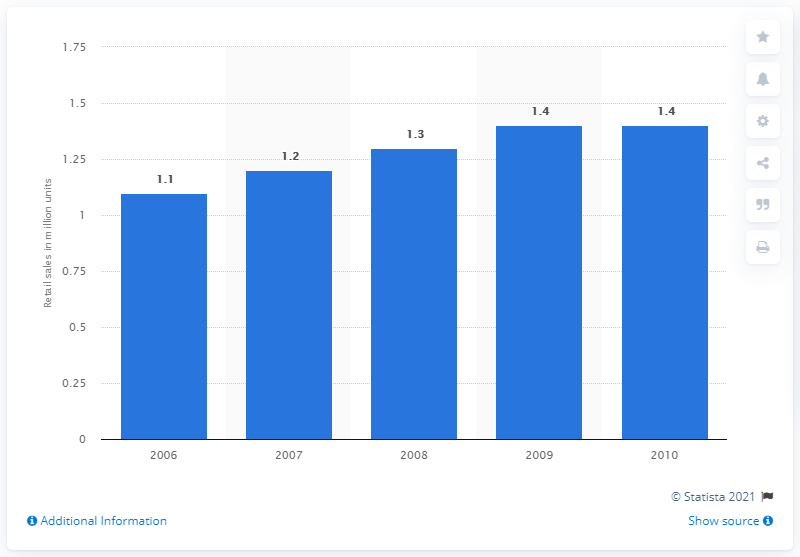Highlight a few significant elements in this photo. In 2010, the retail sales of espresso machines in the United States totaled approximately 1.4 million units. 